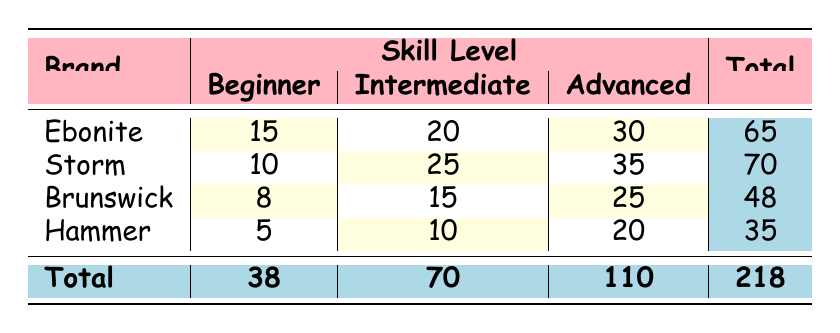What brand had the highest purchases by beginners? Referring to the table, Ebonite shows the highest purchases at 15 by beginners.
Answer: Ebonite How many total purchases were made by advanced players across all brands? Looking under the advanced skill level, the purchases are Ebonite: 30, Storm: 35, Brunswick: 25, and Hammer: 20. Adding these gives 30 + 35 + 25 + 20 = 110.
Answer: 110 Which brand sold the least amount of equipment to beginners? From the beginner row, Hammer has the lowest purchase number with 5.
Answer: Hammer What is the total purchase count for each brand? The totals are calculated as follows: Ebonite: 15 + 20 + 30 = 65, Storm: 10 + 25 + 35 = 70, Brunswick: 8 + 15 + 25 = 48, Hammer: 5 + 10 + 20 = 35.
Answer: Ebonite: 65, Storm: 70, Brunswick: 48, Hammer: 35 Is it true that Storm sold more to advanced players than to beginners? From the table, Storm sold 35 advanced purchases and only 10 to beginners. Since 35 > 10, the statement is true.
Answer: Yes What is the average purchase count for intermediate players across all brands? The total purchases for intermediate players are Ebonite: 20, Storm: 25, Brunswick: 15, and Hammer: 10. Thus, the total is 20 + 25 + 15 + 10 = 70. There are 4 brands, and 70/4 = 17.5.
Answer: 17.5 Which brand has the greatest difference in purchase counts between beginner and advanced players? For each brand, we compute the difference: Ebonite (30 - 15 = 15), Storm (35 - 10 = 25), Brunswick (25 - 8 = 17), Hammer (20 - 5 = 15). The largest is Storm with a difference of 25.
Answer: Storm How many total purchases were made by all brands? The total number of purchases across all brands is calculated by adding the total column: 65 + 70 + 48 + 35 = 218.
Answer: 218 